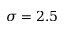<formula> <loc_0><loc_0><loc_500><loc_500>\sigma = 2 . 5</formula> 